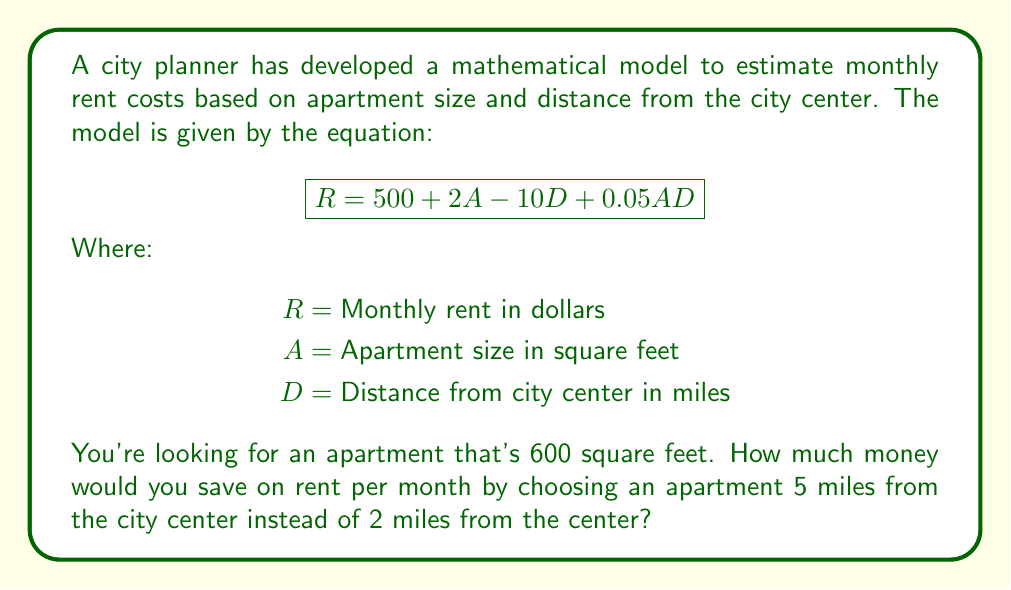Solve this math problem. Let's approach this step-by-step:

1) We'll use the given equation: $R = 500 + 2A - 10D + 0.05AD$

2) We know that $A = 600$ sq ft for both cases. We'll calculate $R$ for $D = 2$ and $D = 5$.

3) For $D = 2$ (2 miles from city center):
   $$R_1 = 500 + 2(600) - 10(2) + 0.05(600)(2)$$
   $$R_1 = 500 + 1200 - 20 + 60$$
   $$R_1 = 1740$$

4) For $D = 5$ (5 miles from city center):
   $$R_2 = 500 + 2(600) - 10(5) + 0.05(600)(5)$$
   $$R_2 = 500 + 1200 - 50 + 150$$
   $$R_2 = 1800$$

5) To find the savings, we subtract $R_2$ from $R_1$:
   $$\text{Savings} = R_1 - R_2 = 1740 - 1800 = -60$$

The negative result indicates that the apartment 5 miles from the center is actually $60 more expensive than the one 2 miles from the center.
Answer: $-$60 dollars (i.e., no savings; it costs $60 more) 